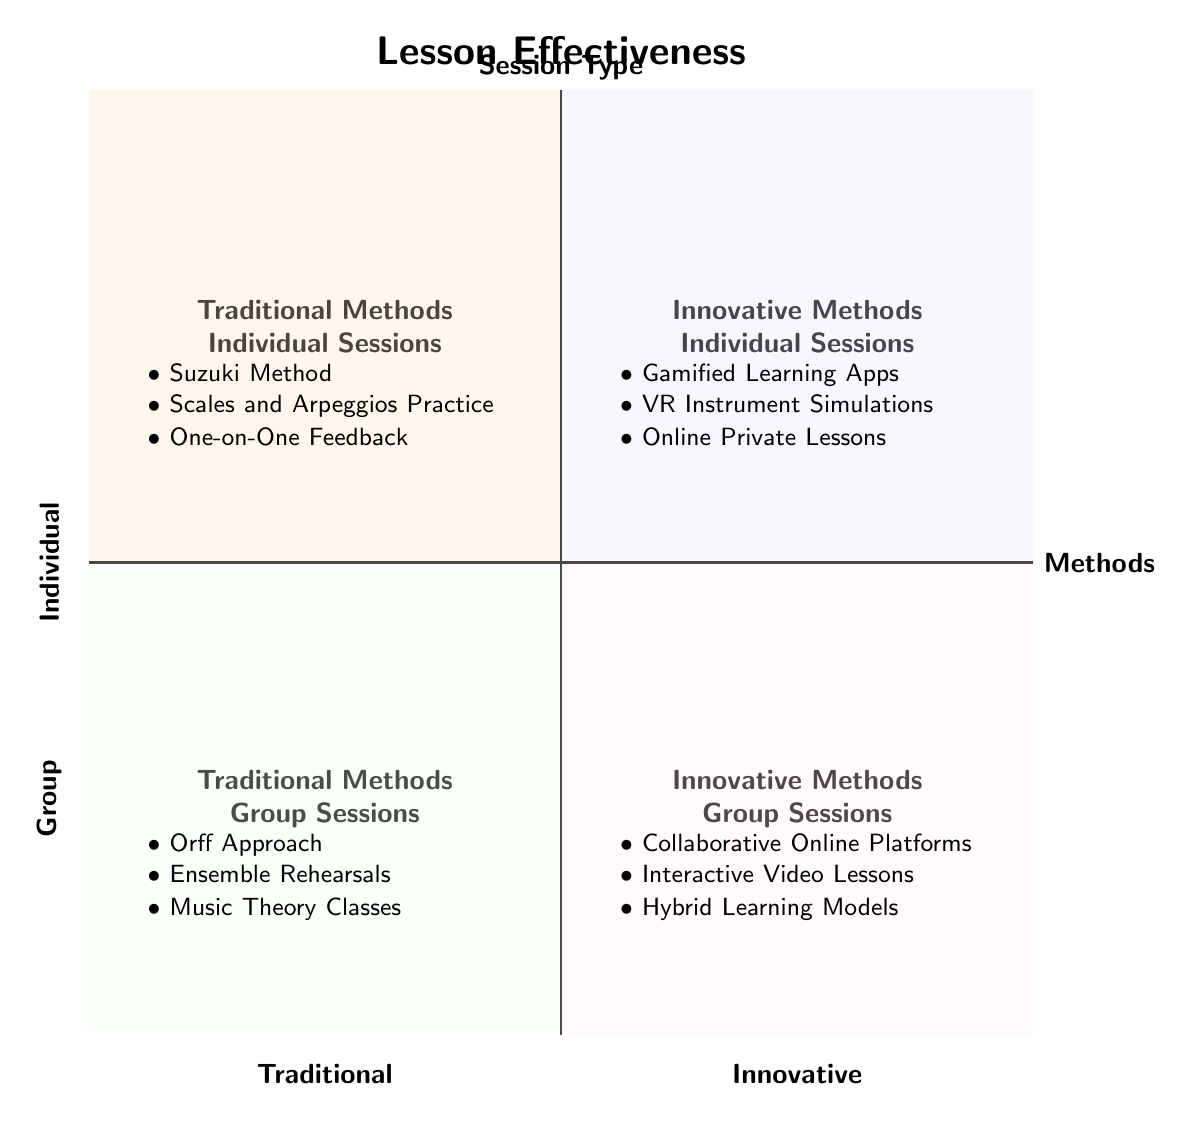What's in the "Traditional Methods - Individual Sessions" quadrant? The question asks to identify the methods listed in the specific quadrant. According to the diagram, three methods are clearly indicated: Suzuki Method, Scales and Arpeggios Practice, and One-on-One Feedback. These directly correspond to the quadrant labeled "Traditional Methods - Individual Sessions."
Answer: Suzuki Method, Scales and Arpeggios Practice, One-on-One Feedback Which session type is associated with the "Gamified Learning Apps"? This question requires identifying in which quadrant the "Gamified Learning Apps" are located. Looking at the diagram, "Gamified Learning Apps" can be found in the "Innovative Methods - Individual Sessions" quadrant. Thus, it corresponds to the Individual session type.
Answer: Individual How many methods are listed under "Innovative Methods - Group Sessions"? The question asks for the count of methods present in this section. By examining the diagram, three methods are mentioned: Collaborative Online Platforms, Interactive Video Lessons, and Hybrid Learning Models, leading to the conclusion that the count is three.
Answer: 3 What is the relationship between "Orff Approach" and "Gamified Learning Apps"? This question asks for a relational understanding of where these items are positioned within the chart. The "Orff Approach" is located in the "Traditional Methods - Group Sessions" quadrant, while "Gamified Learning Apps" is in the "Innovative Methods - Individual Sessions" quadrant, showing a contrast between traditional group methods and innovative individual methods.
Answer: Contrast Which quadrant contains both group sessions and traditional methods? This inquiry focuses on identifying the specific quadrant characterized by both being Traditional and Group. In reviewing the diagram, it is clear that the quadrant titled "Traditional Methods - Group Sessions" contains methods relevant to both aspects.
Answer: Traditional Methods - Group Sessions What method is found at the intersection of innovative methods and individual sessions? This question pertains to identifying the method in the relevant quadrant that represents innovative approaches to individual teaching sessions. The "VR Instrument Simulations" method can be clearly identified within the "Innovative Methods - Individual Sessions" quadrant.
Answer: VR Instrument Simulations How many quadrants display innovative methods? To determine the number of quadrants that show innovative methods, we should look at how many quadrants are designated for this type. There are two quadrants labeled "Innovative Methods - Individual Sessions" and "Innovative Methods - Group Sessions," confirming that the total number is two.
Answer: 2 Which method appears in both group sessions and innovative methods? This question requires considering the quadrants for overlaps or shared methods. Since the given data specifies unique methods in each quadrant with no repeated references, there are no shared methods between the group sessions and innovative methods. Therefore, the answer is none.
Answer: None 